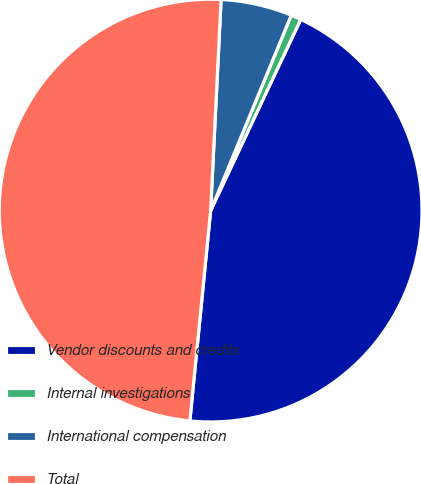Convert chart. <chart><loc_0><loc_0><loc_500><loc_500><pie_chart><fcel>Vendor discounts and credits<fcel>Internal investigations<fcel>International compensation<fcel>Total<nl><fcel>44.56%<fcel>0.78%<fcel>5.44%<fcel>49.22%<nl></chart> 